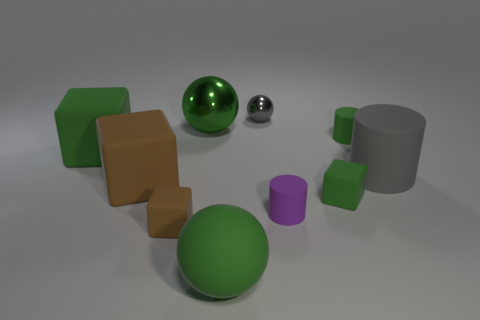What number of other objects are there of the same color as the small sphere?
Provide a succinct answer. 1. Are there fewer small metal things than big red metallic objects?
Offer a very short reply. No. What number of other objects are there of the same material as the big green cube?
Offer a very short reply. 7. What is the size of the other brown rubber object that is the same shape as the tiny brown rubber thing?
Your answer should be very brief. Large. Do the gray thing that is in front of the big green metallic ball and the green ball in front of the large gray cylinder have the same material?
Provide a short and direct response. Yes. Are there fewer gray rubber things to the left of the purple cylinder than green metallic things?
Keep it short and to the point. Yes. Is there any other thing that has the same shape as the big brown rubber thing?
Give a very brief answer. Yes. What is the color of the other tiny rubber thing that is the same shape as the tiny brown rubber thing?
Make the answer very short. Green. There is a sphere that is in front of the gray cylinder; does it have the same size as the tiny gray ball?
Provide a short and direct response. No. What is the size of the green ball right of the metal thing that is left of the small ball?
Offer a very short reply. Large. 